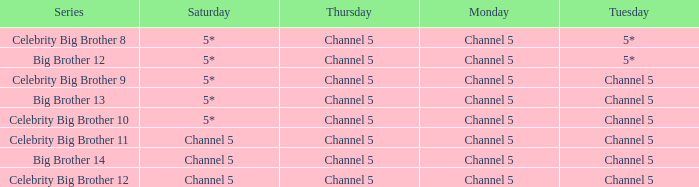Which Thursday does big brother 13 air? Channel 5. 